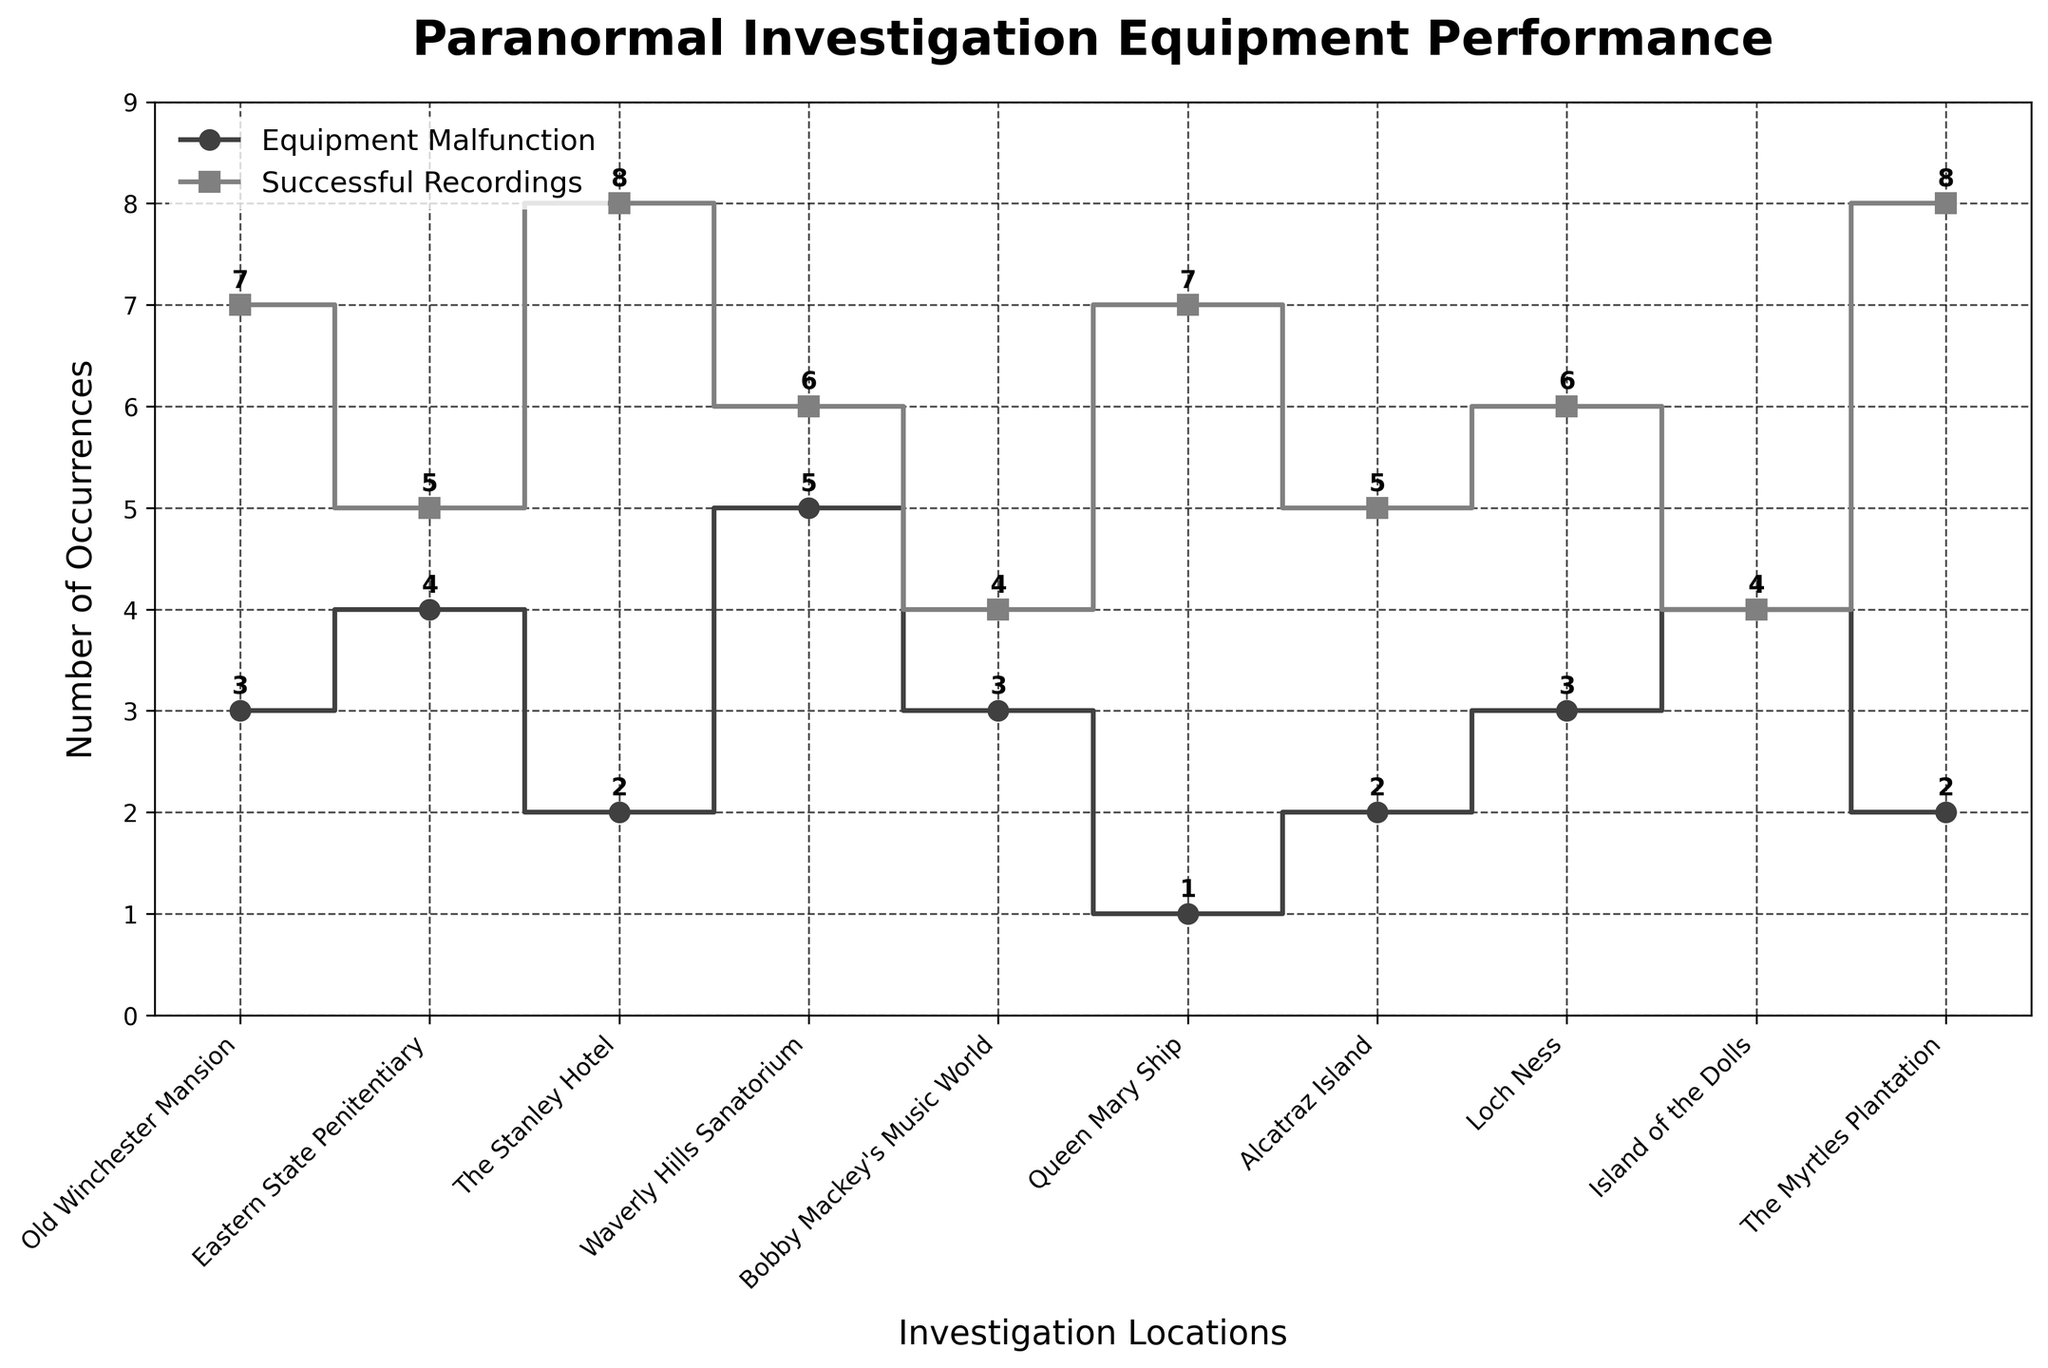What is the title of the figure? The title of the figure can be found at the top, written in a larger and bold font. It reads "Paranormal Investigation Equipment Performance".
Answer: Paranormal Investigation Equipment Performance What are the labels on the X and Y axes? The X-axis label is found below the horizontal line and reads "Investigation Locations", and the Y-axis label is found to the left of the vertical line and reads "Number of Occurrences".
Answer: Investigation Locations, Number of Occurrences How many equipment malfunctions were reported at the Queen Mary Ship? Locating the Queen Mary Ship on the X-axis and tracing it vertically to the step indicating malfunctions, we see a marker at 1.
Answer: 1 Which location had the highest number of successful recordings? Checking all the 'Successful Recordings' steps, the highest point is at The Stanley Hotel and The Myrtles Plantation, both with markers at 8.
Answer: The Stanley Hotel, The Myrtles Plantation How do equipment malfunctions at Waverly Hills Sanatorium compare to those at Bobby Mackey's Music World? At Waverly Hills Sanatorium, malfunctions are marked at 5. At Bobby Mackey's Music World, malfunctions are marked at 3. Thus, Waverly Hills Sanatorium has 2 more malfunctions.
Answer: Waverly Hills Sanatorium has 2 more malfunctions What is the sum of successful recordings at Alcatraz Island and Loch Ness? Alcatraz Island has 5 successful recordings, and Loch Ness has 6. The sum is 5 + 6.
Answer: 11 Which location had an equal number of malfunctions and successful recordings? The Island of the Dolls has both malfunctions and successful recordings marked at 4.
Answer: Island of the Dolls How many total equipment malfunctions were reported across all locations? Summing up the malfunctions across all locations: 3 + 4 + 2 + 5 + 3 + 1 + 2 + 3 + 4 + 2 = 29.
Answer: 29 What is the difference between the successful recordings at Eastern State Penitentiary and Old Winchester Mansion? Eastern State Penitentiary has 5 successful recordings, while Old Winchester Mansion has 7. The difference is 7 - 5.
Answer: 2 Among the listed locations, which one has the least number of malfunctions, and how many are there? By checking all the Equipment Malfunction steps, the Queen Mary Ship has the lowest number with a marker at 1.
Answer: Queen Mary Ship, 1 